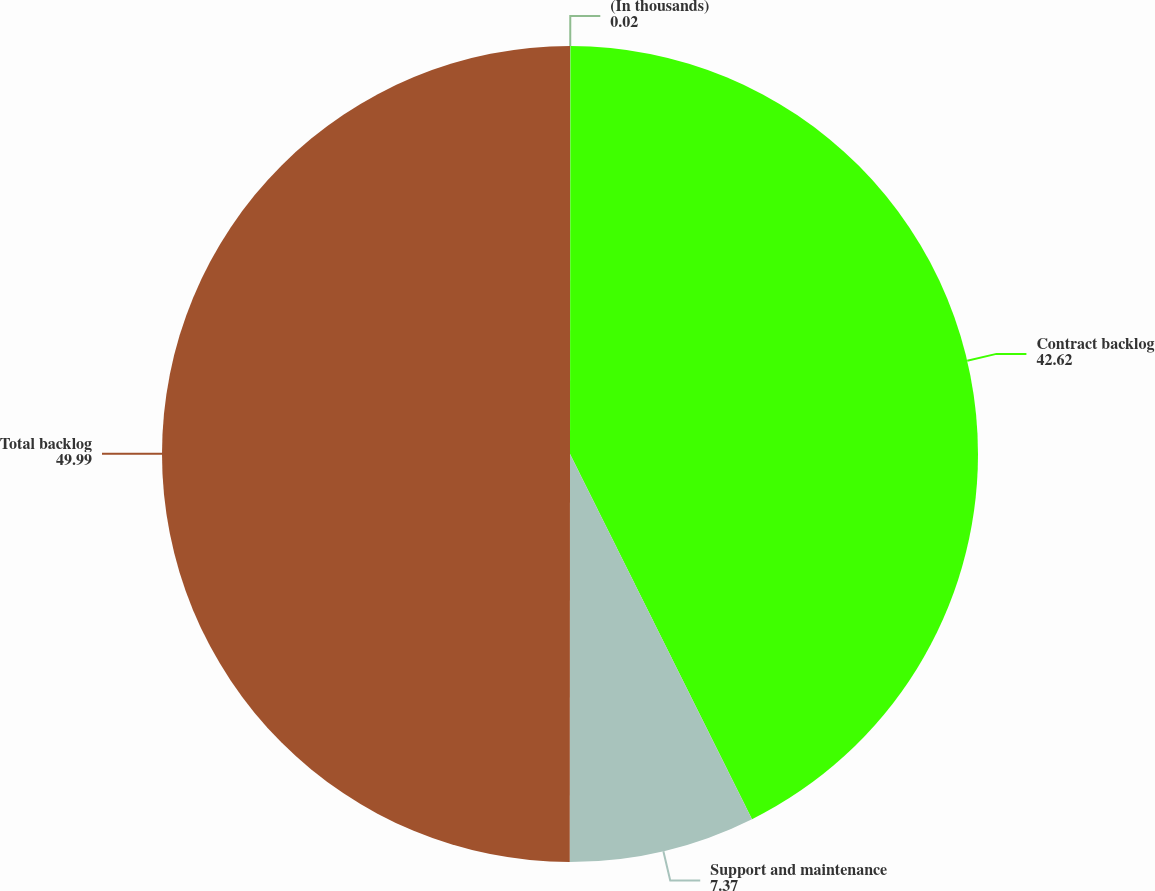Convert chart to OTSL. <chart><loc_0><loc_0><loc_500><loc_500><pie_chart><fcel>(In thousands)<fcel>Contract backlog<fcel>Support and maintenance<fcel>Total backlog<nl><fcel>0.02%<fcel>42.62%<fcel>7.37%<fcel>49.99%<nl></chart> 